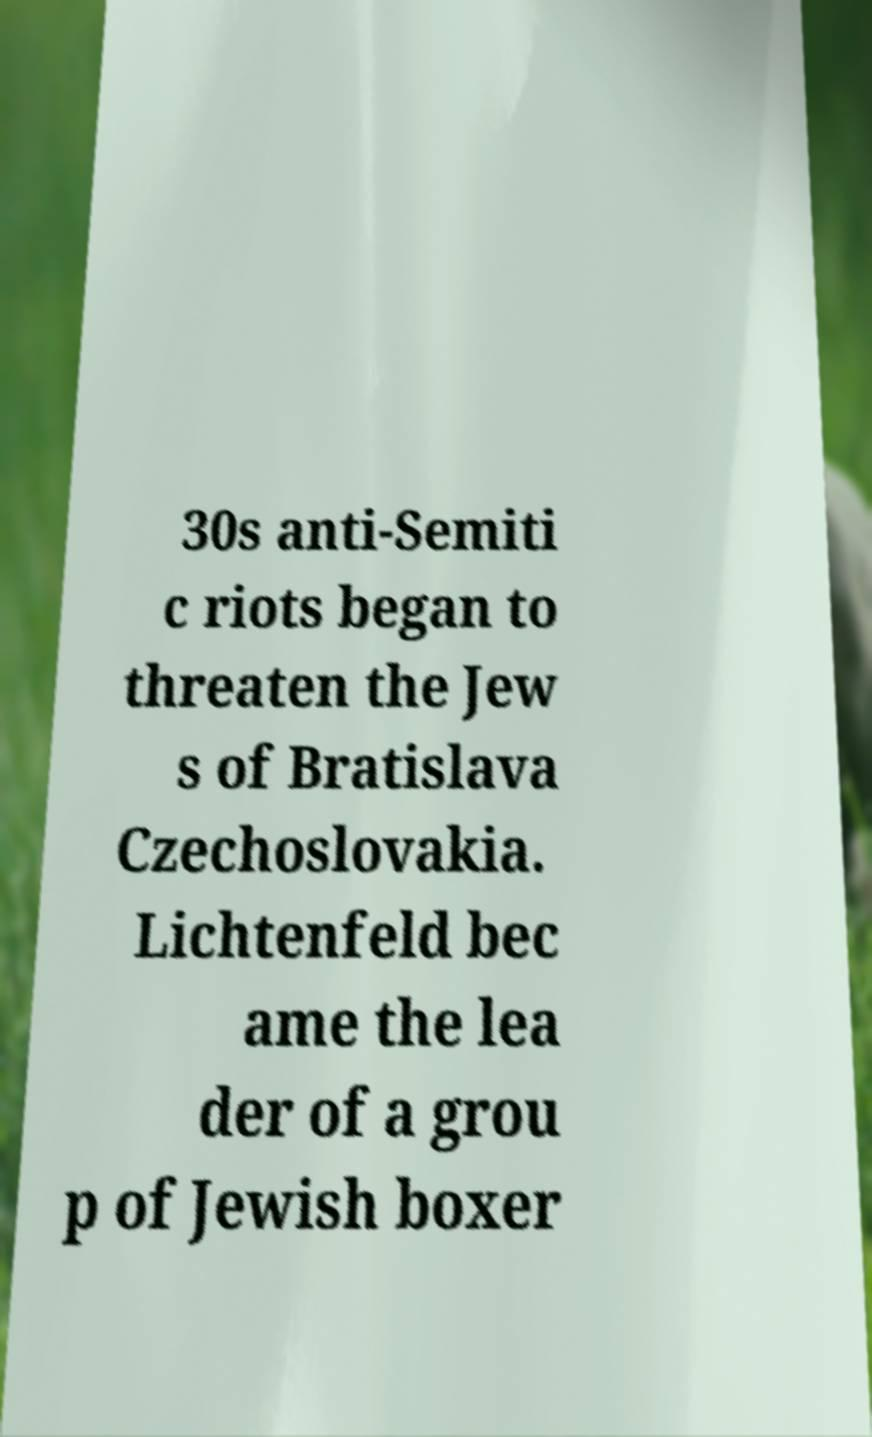What messages or text are displayed in this image? I need them in a readable, typed format. 30s anti-Semiti c riots began to threaten the Jew s of Bratislava Czechoslovakia. Lichtenfeld bec ame the lea der of a grou p of Jewish boxer 